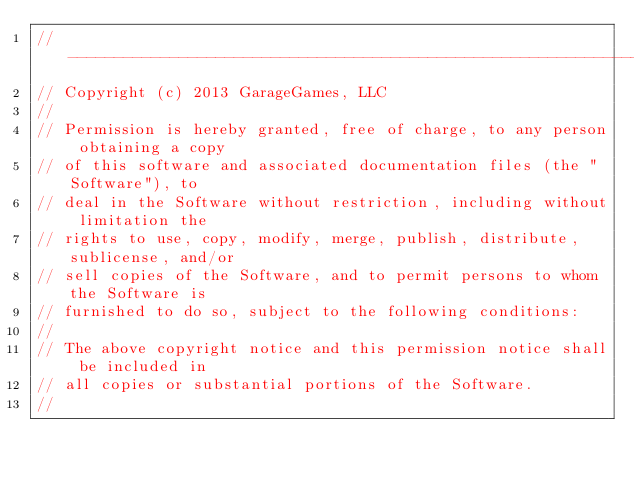<code> <loc_0><loc_0><loc_500><loc_500><_ObjectiveC_>//-----------------------------------------------------------------------------
// Copyright (c) 2013 GarageGames, LLC
//
// Permission is hereby granted, free of charge, to any person obtaining a copy
// of this software and associated documentation files (the "Software"), to
// deal in the Software without restriction, including without limitation the
// rights to use, copy, modify, merge, publish, distribute, sublicense, and/or
// sell copies of the Software, and to permit persons to whom the Software is
// furnished to do so, subject to the following conditions:
//
// The above copyright notice and this permission notice shall be included in
// all copies or substantial portions of the Software.
//</code> 